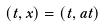Convert formula to latex. <formula><loc_0><loc_0><loc_500><loc_500>( t , x ) = ( t , a t )</formula> 